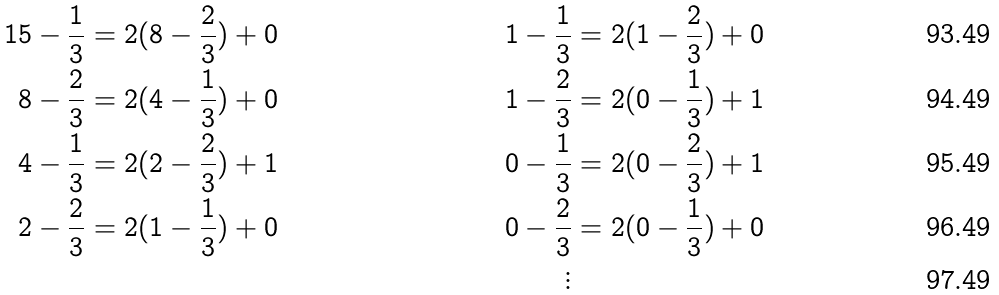Convert formula to latex. <formula><loc_0><loc_0><loc_500><loc_500>1 5 - \frac { 1 } { 3 } & = 2 ( 8 - \frac { 2 } { 3 } ) + 0 & 1 - \frac { 1 } { 3 } & = 2 ( 1 - \frac { 2 } { 3 } ) + 0 \\ 8 - \frac { 2 } { 3 } & = 2 ( 4 - \frac { 1 } { 3 } ) + 0 & 1 - \frac { 2 } { 3 } & = 2 ( 0 - \frac { 1 } { 3 } ) + 1 \\ 4 - \frac { 1 } { 3 } & = 2 ( 2 - \frac { 2 } { 3 } ) + 1 & 0 - \frac { 1 } { 3 } & = 2 ( 0 - \frac { 2 } { 3 } ) + 1 \\ 2 - \frac { 2 } { 3 } & = 2 ( 1 - \frac { 1 } { 3 } ) + 0 & 0 - \frac { 2 } { 3 } & = 2 ( 0 - \frac { 1 } { 3 } ) + 0 \\ & & \vdots</formula> 